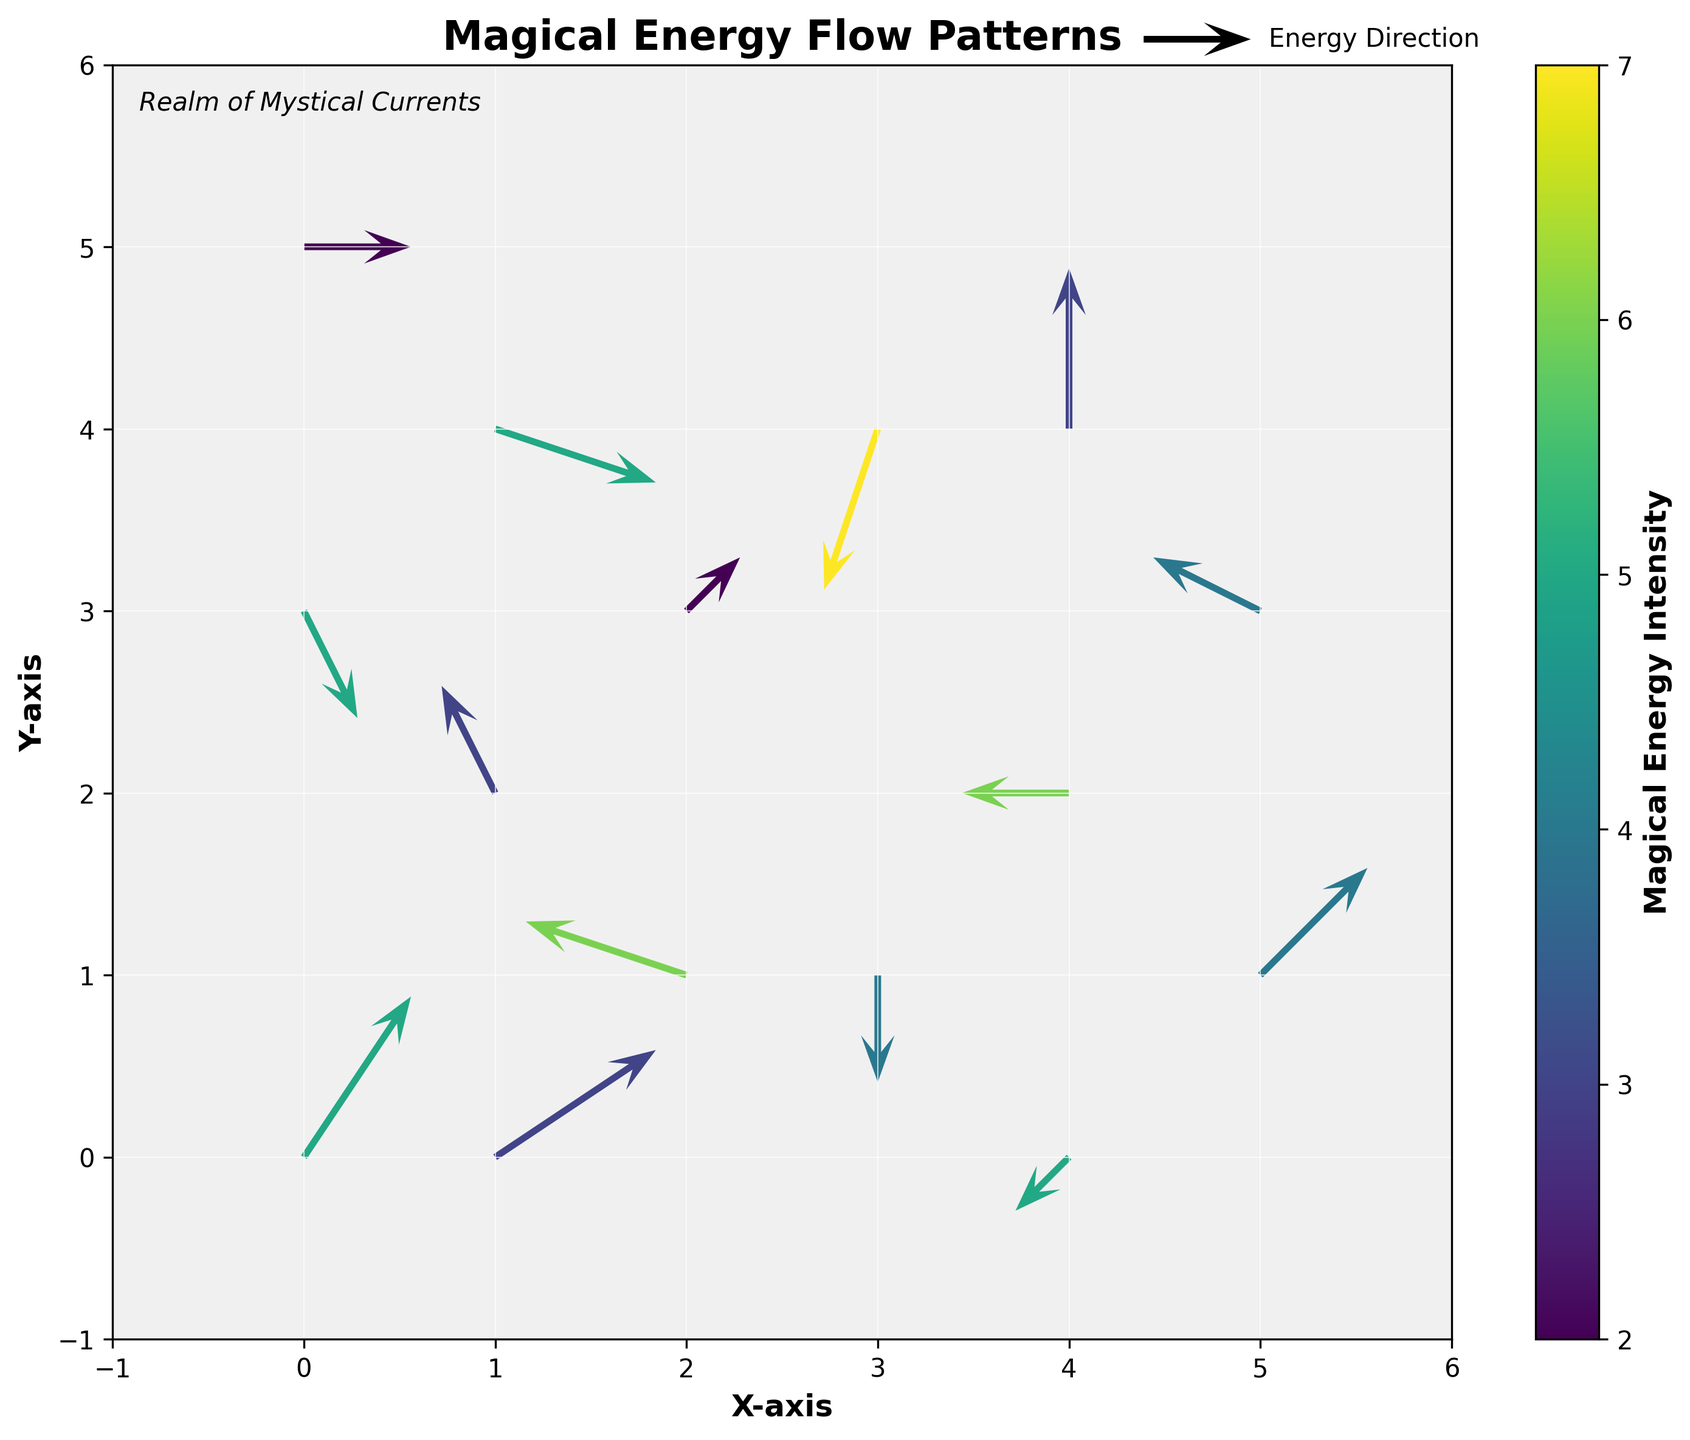What's the title of the figure? The title of the figure is usually prominently displayed at the top and provides a summary of what the figure is about. In this case, it is written in bold.
Answer: Magical Energy Flow Patterns What does the color represent in this figure? The color in the figure represents the intensity of magical energy, with a color gradient shown in the color bar on the right side of the plot. Darker colors typically indicate higher intensity.
Answer: Magical Energy Intensity Which axis represents the horizontal movement in the magical realm? The labels on the axes clearly indicate that the horizontal movement is represented by the X-axis, which is typically on the bottom.
Answer: X-axis What is the direction of the magical flow at the point (1, 4)? To determine the direction of the magical flow, observe the arrow at the coordinate (1, 4). The arrow points towards its direction. Here, it points south-east.
Answer: South-east What is the intensity value of the highest magical energy flow? By observing the color bar and matching it with the darkest color in the plot, we can find the highest intensity value. The darkest color in this plot corresponds to an intensity of 7.
Answer: 7 Are there more arrows pointing to the north or to the east in this figure? By visually inspecting the directions of all arrows, count the number pointing primarily northward versus those pointing eastward. Northward arrows seem to be fewer compared to those pointing eastward.
Answer: Eastward What's the average intensity of the arrows at coordinates (2,1) and (2,3)? Identify the arrows at (2,1) and (2,3), observe their corresponding intensities (6 and 2), and calculate the average: (6 + 2) / 2 = 4.
Answer: 4 Which point has the arrow with the strongest diagonal movement? Compare all arrows for those that are diagonal (having both x and y components) and identify the strongest one by its length and direction. The arrow at (3, 4) has a strong diagonal movement with components -1 and -3.
Answer: (3, 4) In which quadrant of the grid is the majority of the high-intensity magical energy located? Divide the grid visually into four quadrants and identify the regions where the highest intensity arrows are located. The majority of high-intensity arrows seem to be in the lower right quadrant.
Answer: Lower right Compare the energy flow at (1,2) and (2,3). Which has a greater intensity and what are their directions? Look at the arrows at (1,2) and (2,3) and compare their color intensity. The arrow at (1,2) has an intensity of 3, and it flows east. The arrow at (2,3) has an intensity of 2, and it flows north-east. Thus, (1,2) has greater intensity.
Answer: (1,2) has greater intensity, flow directions are east (1,2) and north-east (2,3) 